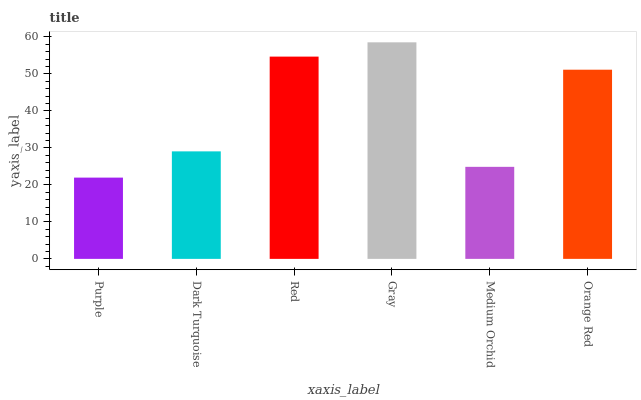Is Purple the minimum?
Answer yes or no. Yes. Is Gray the maximum?
Answer yes or no. Yes. Is Dark Turquoise the minimum?
Answer yes or no. No. Is Dark Turquoise the maximum?
Answer yes or no. No. Is Dark Turquoise greater than Purple?
Answer yes or no. Yes. Is Purple less than Dark Turquoise?
Answer yes or no. Yes. Is Purple greater than Dark Turquoise?
Answer yes or no. No. Is Dark Turquoise less than Purple?
Answer yes or no. No. Is Orange Red the high median?
Answer yes or no. Yes. Is Dark Turquoise the low median?
Answer yes or no. Yes. Is Red the high median?
Answer yes or no. No. Is Red the low median?
Answer yes or no. No. 